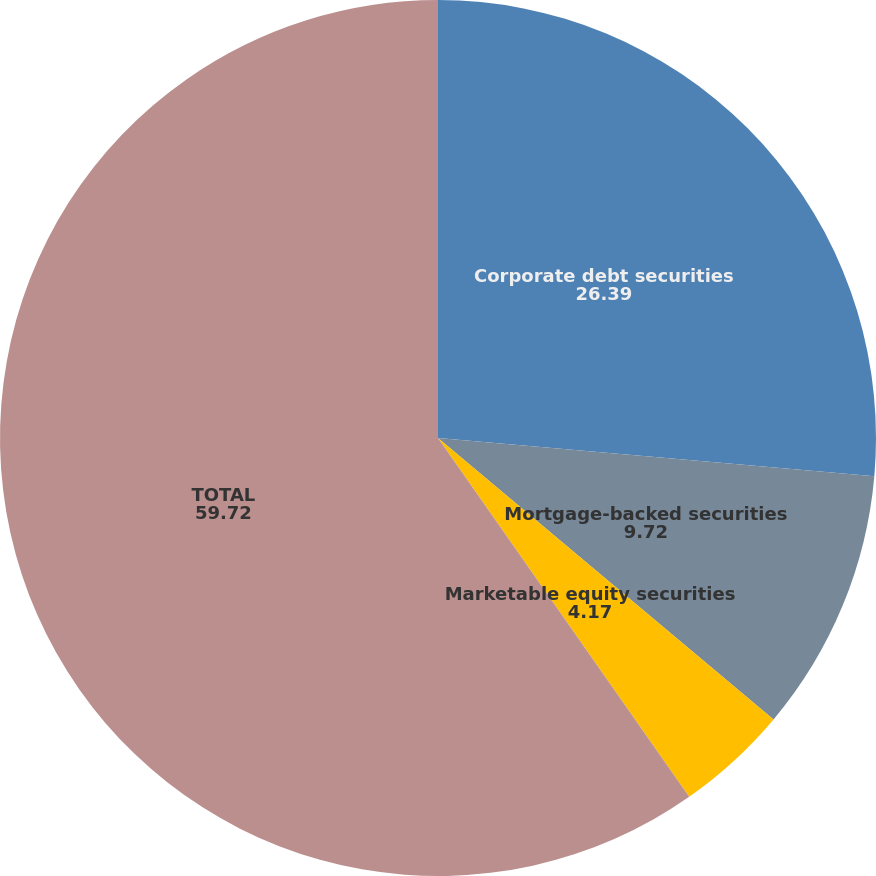Convert chart to OTSL. <chart><loc_0><loc_0><loc_500><loc_500><pie_chart><fcel>Corporate debt securities<fcel>Mortgage-backed securities<fcel>Marketable equity securities<fcel>TOTAL<nl><fcel>26.39%<fcel>9.72%<fcel>4.17%<fcel>59.72%<nl></chart> 